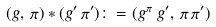<formula> <loc_0><loc_0><loc_500><loc_500>( g , \, \pi ) \ast ( g ^ { \prime } \, \pi ^ { \prime } ) \colon = ( g ^ { \pi \, } \, g ^ { \prime } , \, \pi \, \pi ^ { \prime } )</formula> 